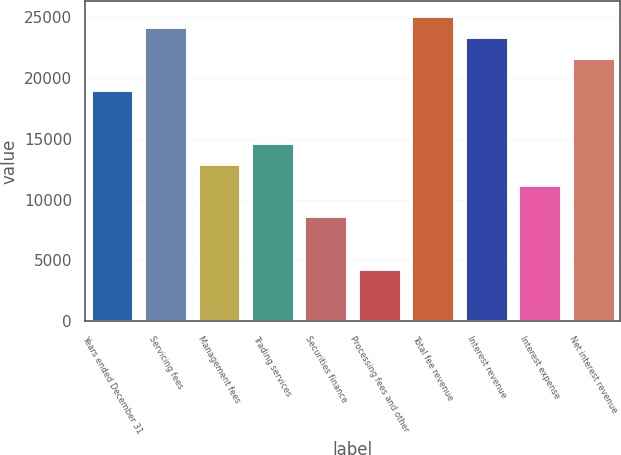Convert chart. <chart><loc_0><loc_0><loc_500><loc_500><bar_chart><fcel>Years ended December 31<fcel>Servicing fees<fcel>Management fees<fcel>Trading services<fcel>Securities finance<fcel>Processing fees and other<fcel>Total fee revenue<fcel>Interest revenue<fcel>Interest expense<fcel>Net interest revenue<nl><fcel>19003.8<fcel>24185.7<fcel>12958.2<fcel>14685.5<fcel>8639.96<fcel>4321.71<fcel>25049.3<fcel>23322<fcel>11230.9<fcel>21594.7<nl></chart> 